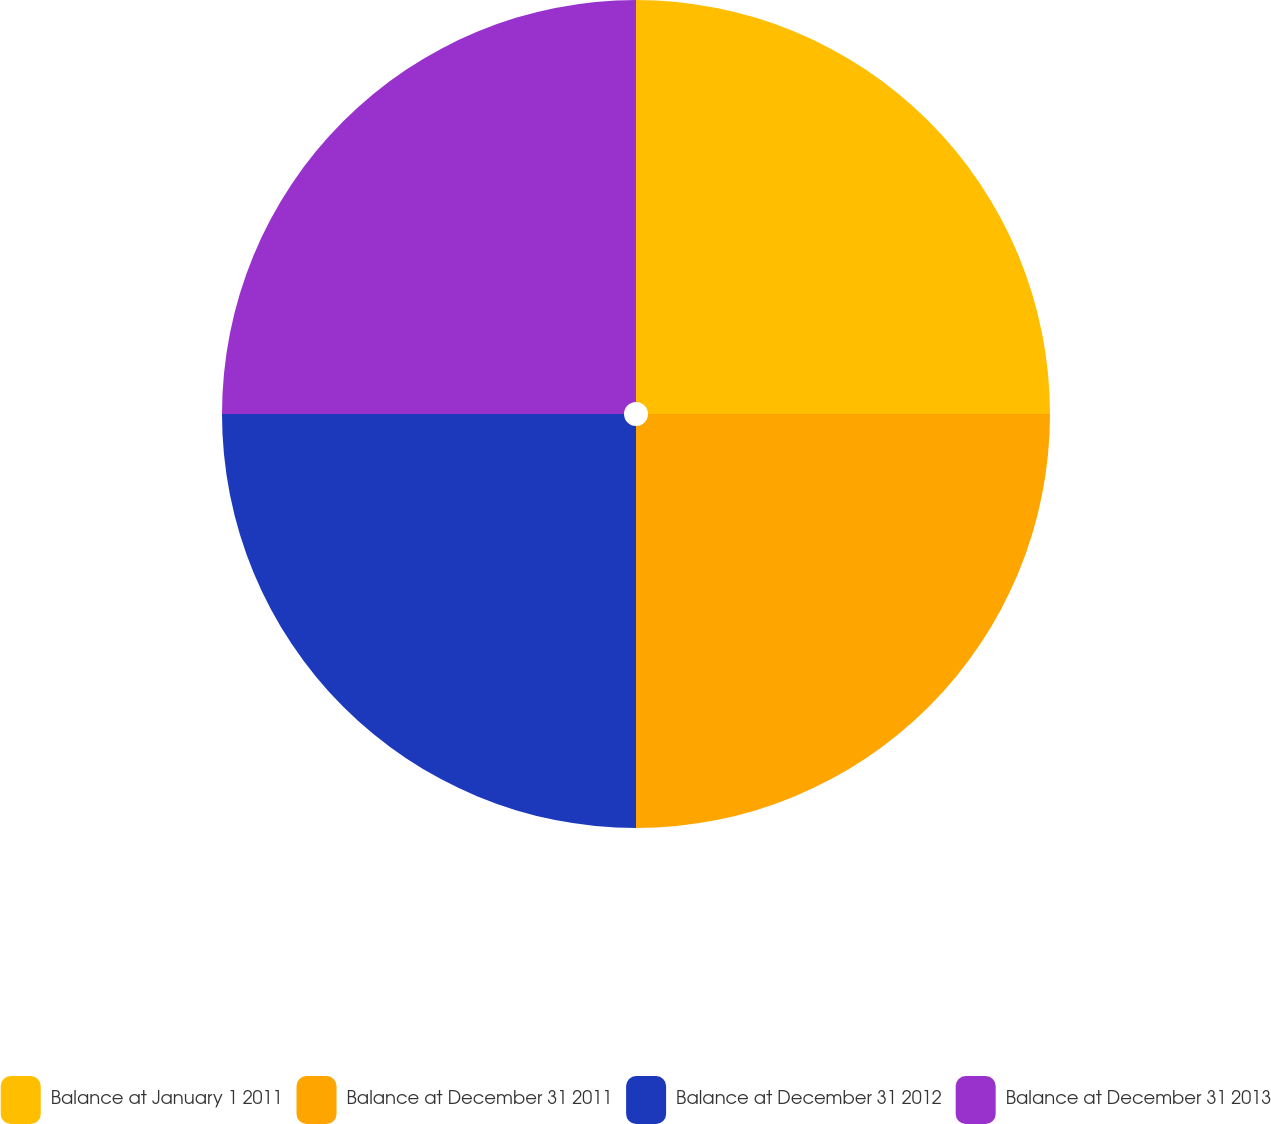<chart> <loc_0><loc_0><loc_500><loc_500><pie_chart><fcel>Balance at January 1 2011<fcel>Balance at December 31 2011<fcel>Balance at December 31 2012<fcel>Balance at December 31 2013<nl><fcel>25.0%<fcel>25.0%<fcel>25.0%<fcel>25.0%<nl></chart> 